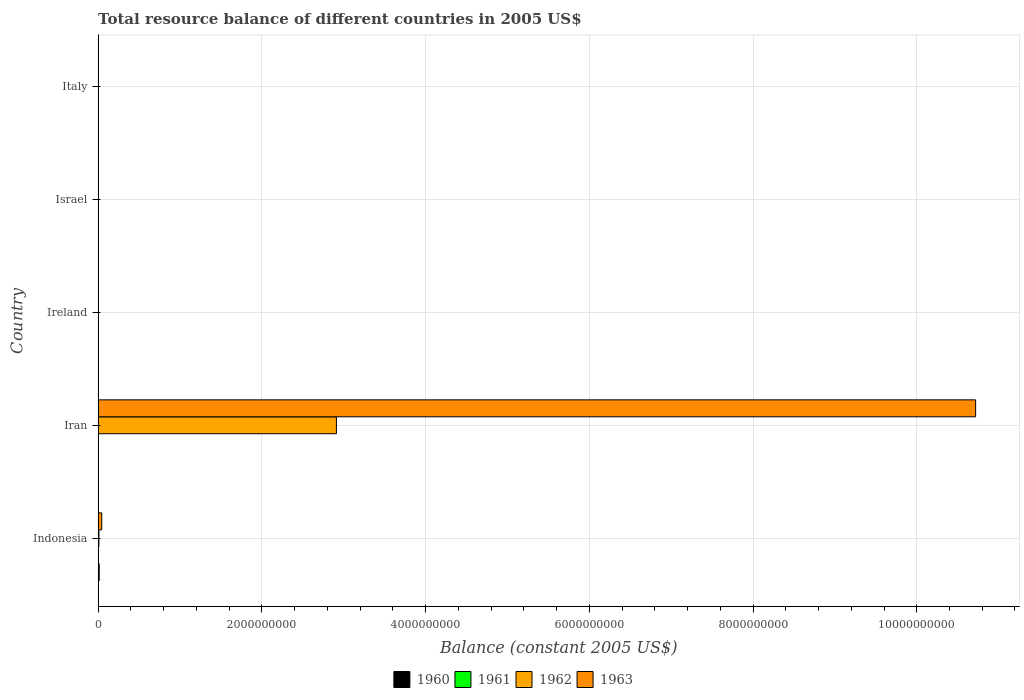Are the number of bars on each tick of the Y-axis equal?
Provide a succinct answer. No. What is the label of the 5th group of bars from the top?
Offer a very short reply. Indonesia. In how many cases, is the number of bars for a given country not equal to the number of legend labels?
Offer a terse response. 4. What is the total resource balance in 1962 in Indonesia?
Offer a very short reply. 9.90e+06. Across all countries, what is the maximum total resource balance in 1961?
Keep it short and to the point. 2000. Across all countries, what is the minimum total resource balance in 1960?
Your answer should be compact. 0. In which country was the total resource balance in 1962 maximum?
Offer a terse response. Iran. What is the total total resource balance in 1960 in the graph?
Your response must be concise. 1.30e+07. What is the difference between the total resource balance in 1960 in Indonesia and that in Israel?
Your answer should be compact. 1.30e+07. What is the difference between the total resource balance in 1963 in Iran and the total resource balance in 1962 in Indonesia?
Ensure brevity in your answer.  1.07e+1. What is the average total resource balance in 1960 per country?
Offer a terse response. 2.60e+06. What is the difference between the total resource balance in 1960 and total resource balance in 1963 in Israel?
Keep it short and to the point. -1.96e+04. In how many countries, is the total resource balance in 1961 greater than 6800000000 US$?
Keep it short and to the point. 0. Is the difference between the total resource balance in 1960 in Indonesia and Israel greater than the difference between the total resource balance in 1963 in Indonesia and Israel?
Give a very brief answer. No. What is the difference between the highest and the second highest total resource balance in 1962?
Offer a very short reply. 2.90e+09. In how many countries, is the total resource balance in 1962 greater than the average total resource balance in 1962 taken over all countries?
Provide a short and direct response. 1. How many bars are there?
Offer a terse response. 9. How many countries are there in the graph?
Your response must be concise. 5. Are the values on the major ticks of X-axis written in scientific E-notation?
Keep it short and to the point. No. Does the graph contain any zero values?
Make the answer very short. Yes. Does the graph contain grids?
Keep it short and to the point. Yes. Where does the legend appear in the graph?
Ensure brevity in your answer.  Bottom center. What is the title of the graph?
Offer a very short reply. Total resource balance of different countries in 2005 US$. Does "1976" appear as one of the legend labels in the graph?
Ensure brevity in your answer.  No. What is the label or title of the X-axis?
Give a very brief answer. Balance (constant 2005 US$). What is the label or title of the Y-axis?
Your answer should be compact. Country. What is the Balance (constant 2005 US$) in 1960 in Indonesia?
Your response must be concise. 1.30e+07. What is the Balance (constant 2005 US$) of 1961 in Indonesia?
Ensure brevity in your answer.  0. What is the Balance (constant 2005 US$) in 1962 in Indonesia?
Your response must be concise. 9.90e+06. What is the Balance (constant 2005 US$) of 1963 in Indonesia?
Give a very brief answer. 4.42e+07. What is the Balance (constant 2005 US$) in 1961 in Iran?
Offer a terse response. 0. What is the Balance (constant 2005 US$) in 1962 in Iran?
Offer a terse response. 2.91e+09. What is the Balance (constant 2005 US$) in 1963 in Iran?
Make the answer very short. 1.07e+1. What is the Balance (constant 2005 US$) in 1962 in Ireland?
Provide a short and direct response. 0. What is the Balance (constant 2005 US$) of 1963 in Ireland?
Offer a terse response. 0. What is the Balance (constant 2005 US$) of 1960 in Israel?
Your answer should be very brief. 4100. What is the Balance (constant 2005 US$) in 1962 in Israel?
Your response must be concise. 8000. What is the Balance (constant 2005 US$) in 1963 in Israel?
Provide a short and direct response. 2.37e+04. What is the Balance (constant 2005 US$) of 1961 in Italy?
Your response must be concise. 0. Across all countries, what is the maximum Balance (constant 2005 US$) in 1960?
Offer a terse response. 1.30e+07. Across all countries, what is the maximum Balance (constant 2005 US$) in 1962?
Your response must be concise. 2.91e+09. Across all countries, what is the maximum Balance (constant 2005 US$) of 1963?
Keep it short and to the point. 1.07e+1. Across all countries, what is the minimum Balance (constant 2005 US$) of 1961?
Ensure brevity in your answer.  0. Across all countries, what is the minimum Balance (constant 2005 US$) of 1963?
Provide a short and direct response. 0. What is the total Balance (constant 2005 US$) in 1960 in the graph?
Provide a short and direct response. 1.30e+07. What is the total Balance (constant 2005 US$) in 1961 in the graph?
Give a very brief answer. 2000. What is the total Balance (constant 2005 US$) of 1962 in the graph?
Give a very brief answer. 2.92e+09. What is the total Balance (constant 2005 US$) in 1963 in the graph?
Offer a terse response. 1.08e+1. What is the difference between the Balance (constant 2005 US$) of 1962 in Indonesia and that in Iran?
Give a very brief answer. -2.90e+09. What is the difference between the Balance (constant 2005 US$) in 1963 in Indonesia and that in Iran?
Give a very brief answer. -1.07e+1. What is the difference between the Balance (constant 2005 US$) of 1960 in Indonesia and that in Israel?
Provide a short and direct response. 1.30e+07. What is the difference between the Balance (constant 2005 US$) of 1962 in Indonesia and that in Israel?
Ensure brevity in your answer.  9.90e+06. What is the difference between the Balance (constant 2005 US$) of 1963 in Indonesia and that in Israel?
Keep it short and to the point. 4.42e+07. What is the difference between the Balance (constant 2005 US$) of 1962 in Iran and that in Israel?
Keep it short and to the point. 2.91e+09. What is the difference between the Balance (constant 2005 US$) of 1963 in Iran and that in Israel?
Ensure brevity in your answer.  1.07e+1. What is the difference between the Balance (constant 2005 US$) of 1960 in Indonesia and the Balance (constant 2005 US$) of 1962 in Iran?
Make the answer very short. -2.90e+09. What is the difference between the Balance (constant 2005 US$) in 1960 in Indonesia and the Balance (constant 2005 US$) in 1963 in Iran?
Your answer should be compact. -1.07e+1. What is the difference between the Balance (constant 2005 US$) in 1962 in Indonesia and the Balance (constant 2005 US$) in 1963 in Iran?
Your answer should be compact. -1.07e+1. What is the difference between the Balance (constant 2005 US$) in 1960 in Indonesia and the Balance (constant 2005 US$) in 1961 in Israel?
Offer a terse response. 1.30e+07. What is the difference between the Balance (constant 2005 US$) in 1960 in Indonesia and the Balance (constant 2005 US$) in 1962 in Israel?
Your answer should be very brief. 1.30e+07. What is the difference between the Balance (constant 2005 US$) in 1960 in Indonesia and the Balance (constant 2005 US$) in 1963 in Israel?
Make the answer very short. 1.30e+07. What is the difference between the Balance (constant 2005 US$) in 1962 in Indonesia and the Balance (constant 2005 US$) in 1963 in Israel?
Your response must be concise. 9.88e+06. What is the difference between the Balance (constant 2005 US$) of 1962 in Iran and the Balance (constant 2005 US$) of 1963 in Israel?
Keep it short and to the point. 2.91e+09. What is the average Balance (constant 2005 US$) of 1960 per country?
Keep it short and to the point. 2.60e+06. What is the average Balance (constant 2005 US$) of 1962 per country?
Your answer should be very brief. 5.84e+08. What is the average Balance (constant 2005 US$) of 1963 per country?
Keep it short and to the point. 2.15e+09. What is the difference between the Balance (constant 2005 US$) of 1960 and Balance (constant 2005 US$) of 1962 in Indonesia?
Offer a very short reply. 3.08e+06. What is the difference between the Balance (constant 2005 US$) of 1960 and Balance (constant 2005 US$) of 1963 in Indonesia?
Keep it short and to the point. -3.12e+07. What is the difference between the Balance (constant 2005 US$) in 1962 and Balance (constant 2005 US$) in 1963 in Indonesia?
Provide a succinct answer. -3.43e+07. What is the difference between the Balance (constant 2005 US$) in 1962 and Balance (constant 2005 US$) in 1963 in Iran?
Offer a terse response. -7.81e+09. What is the difference between the Balance (constant 2005 US$) in 1960 and Balance (constant 2005 US$) in 1961 in Israel?
Give a very brief answer. 2100. What is the difference between the Balance (constant 2005 US$) in 1960 and Balance (constant 2005 US$) in 1962 in Israel?
Provide a short and direct response. -3900. What is the difference between the Balance (constant 2005 US$) in 1960 and Balance (constant 2005 US$) in 1963 in Israel?
Ensure brevity in your answer.  -1.96e+04. What is the difference between the Balance (constant 2005 US$) of 1961 and Balance (constant 2005 US$) of 1962 in Israel?
Ensure brevity in your answer.  -6000. What is the difference between the Balance (constant 2005 US$) in 1961 and Balance (constant 2005 US$) in 1963 in Israel?
Make the answer very short. -2.17e+04. What is the difference between the Balance (constant 2005 US$) in 1962 and Balance (constant 2005 US$) in 1963 in Israel?
Your response must be concise. -1.57e+04. What is the ratio of the Balance (constant 2005 US$) of 1962 in Indonesia to that in Iran?
Provide a succinct answer. 0. What is the ratio of the Balance (constant 2005 US$) in 1963 in Indonesia to that in Iran?
Make the answer very short. 0. What is the ratio of the Balance (constant 2005 US$) in 1960 in Indonesia to that in Israel?
Offer a very short reply. 3166.17. What is the ratio of the Balance (constant 2005 US$) in 1962 in Indonesia to that in Israel?
Keep it short and to the point. 1237.97. What is the ratio of the Balance (constant 2005 US$) in 1963 in Indonesia to that in Israel?
Your answer should be very brief. 1865.71. What is the ratio of the Balance (constant 2005 US$) of 1962 in Iran to that in Israel?
Offer a very short reply. 3.64e+05. What is the ratio of the Balance (constant 2005 US$) in 1963 in Iran to that in Israel?
Give a very brief answer. 4.52e+05. What is the difference between the highest and the second highest Balance (constant 2005 US$) of 1962?
Your answer should be compact. 2.90e+09. What is the difference between the highest and the second highest Balance (constant 2005 US$) in 1963?
Offer a terse response. 1.07e+1. What is the difference between the highest and the lowest Balance (constant 2005 US$) of 1960?
Give a very brief answer. 1.30e+07. What is the difference between the highest and the lowest Balance (constant 2005 US$) in 1962?
Ensure brevity in your answer.  2.91e+09. What is the difference between the highest and the lowest Balance (constant 2005 US$) in 1963?
Make the answer very short. 1.07e+1. 